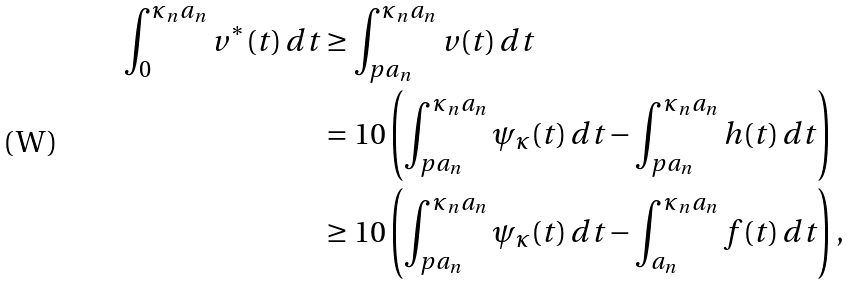Convert formula to latex. <formula><loc_0><loc_0><loc_500><loc_500>\int _ { 0 } ^ { \kappa _ { n } a _ { n } } v ^ { * } ( t ) \, d t & \geq \int _ { p a _ { n } } ^ { \kappa _ { n } a _ { n } } v ( t ) \, d t \\ & = 1 0 \left ( \int _ { p a _ { n } } ^ { \kappa _ { n } a _ { n } } \psi _ { \kappa } ( t ) \, d t - \int _ { p a _ { n } } ^ { \kappa _ { n } a _ { n } } h ( t ) \, d t \right ) \\ & \geq 1 0 \left ( \int _ { p a _ { n } } ^ { \kappa _ { n } a _ { n } } \psi _ { \kappa } ( t ) \, d t - \int _ { a _ { n } } ^ { \kappa _ { n } a _ { n } } f ( t ) \, d t \right ) ,</formula> 